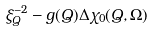<formula> <loc_0><loc_0><loc_500><loc_500>\xi ^ { - 2 } _ { Q } - g ( { Q } ) \Delta \chi _ { 0 } ( { Q } , \Omega )</formula> 